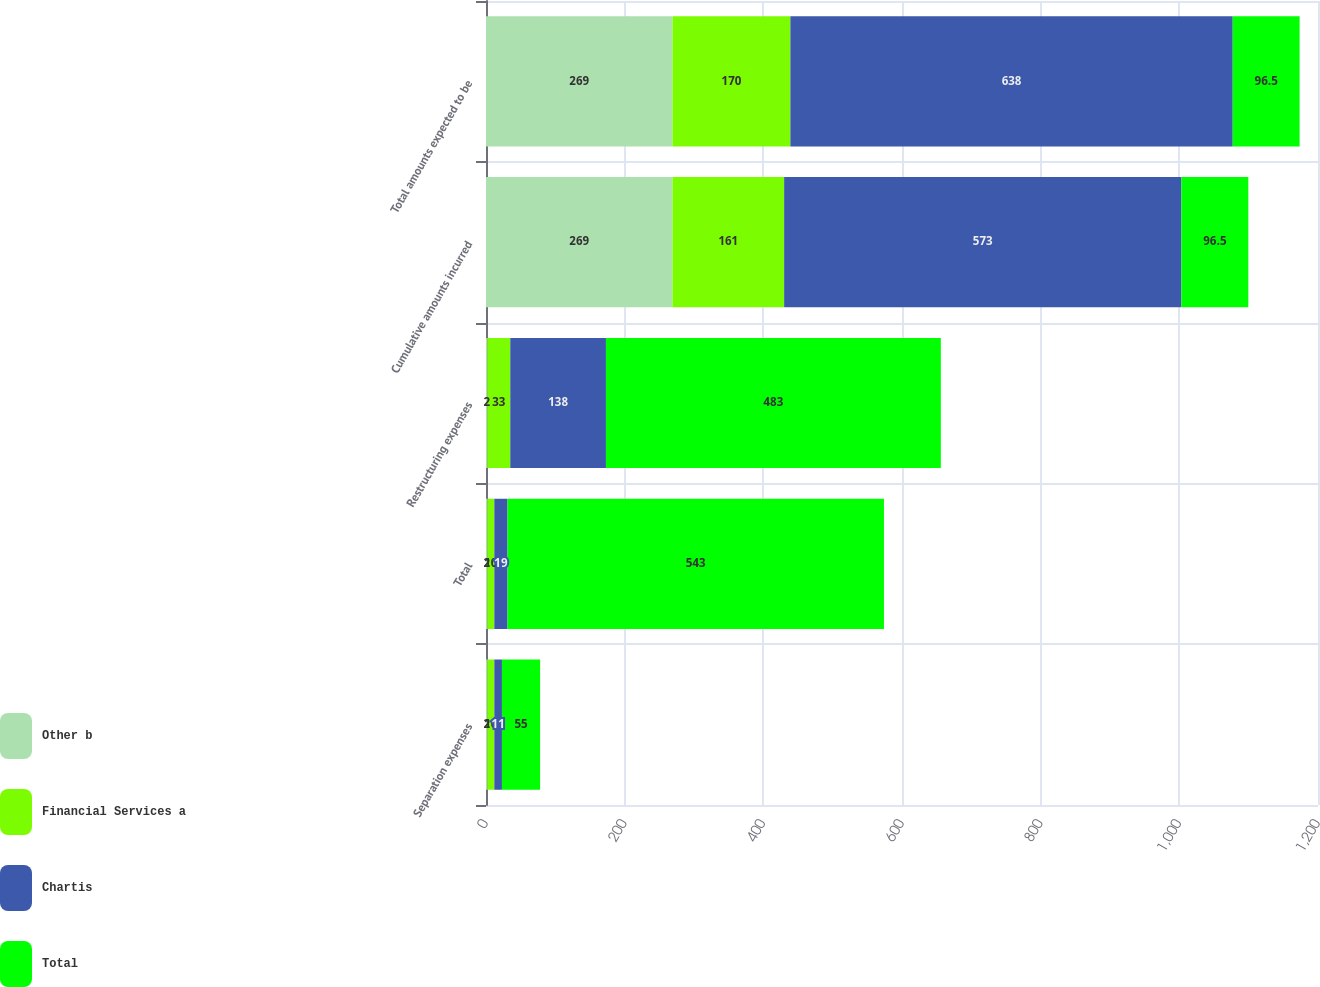<chart> <loc_0><loc_0><loc_500><loc_500><stacked_bar_chart><ecel><fcel>Separation expenses<fcel>Total<fcel>Restructuring expenses<fcel>Cumulative amounts incurred<fcel>Total amounts expected to be<nl><fcel>Other b<fcel>2<fcel>2<fcel>2<fcel>269<fcel>269<nl><fcel>Financial Services a<fcel>10<fcel>10<fcel>33<fcel>161<fcel>170<nl><fcel>Chartis<fcel>11<fcel>19<fcel>138<fcel>573<fcel>638<nl><fcel>Total<fcel>55<fcel>543<fcel>483<fcel>96.5<fcel>96.5<nl></chart> 